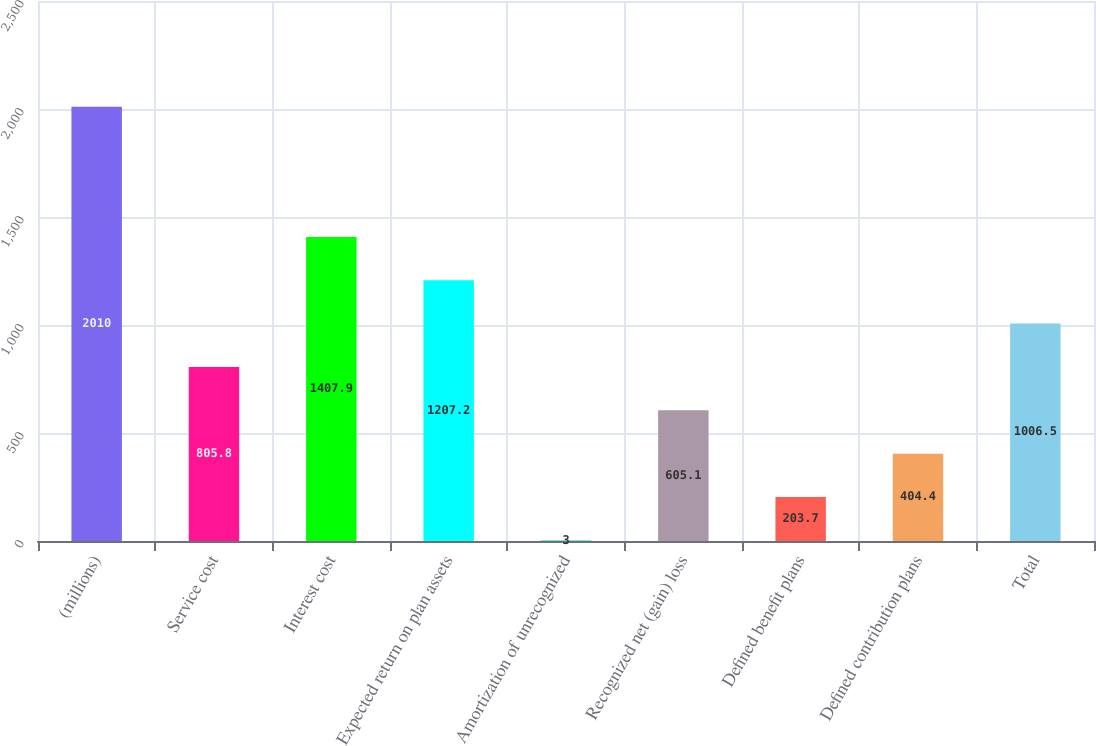Convert chart. <chart><loc_0><loc_0><loc_500><loc_500><bar_chart><fcel>(millions)<fcel>Service cost<fcel>Interest cost<fcel>Expected return on plan assets<fcel>Amortization of unrecognized<fcel>Recognized net (gain) loss<fcel>Defined benefit plans<fcel>Defined contribution plans<fcel>Total<nl><fcel>2010<fcel>805.8<fcel>1407.9<fcel>1207.2<fcel>3<fcel>605.1<fcel>203.7<fcel>404.4<fcel>1006.5<nl></chart> 